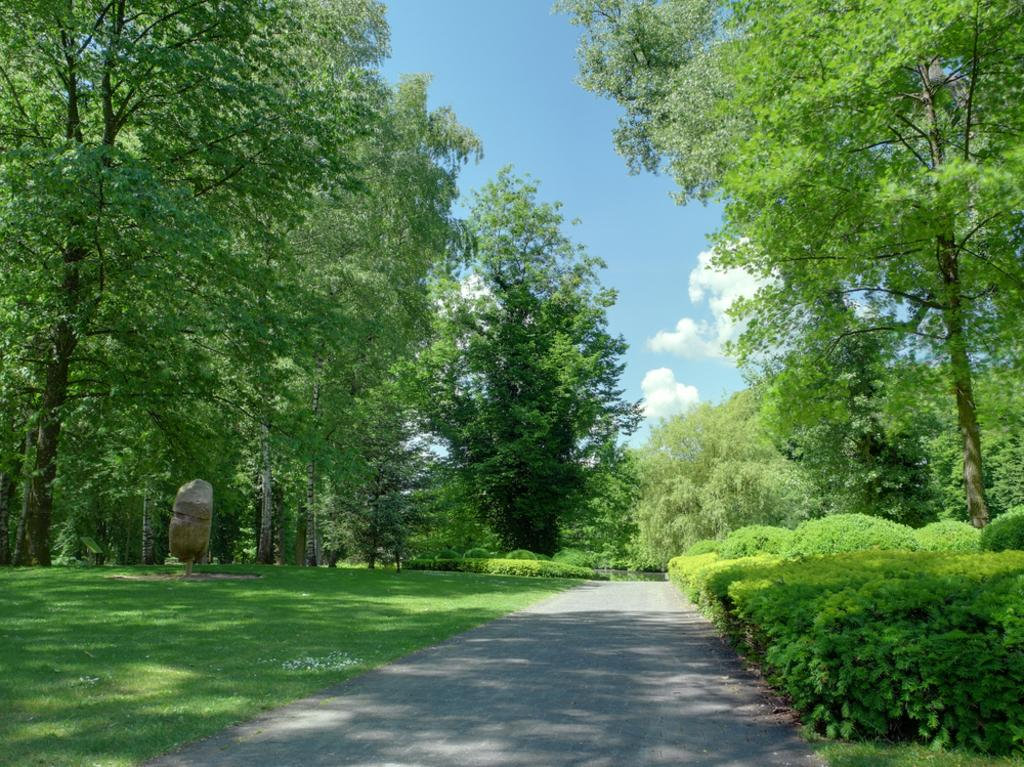What is located at the bottom of the image? There is a road at the bottom of the image. What type of vegetation can be seen on both sides of the image? There are trees on both sides of the image. What type of vegetation is on the left side of the image? There is grass on the left side of the image. What is visible at the top of the image? The sky is visible at the top of the image. Can you see a flock of celery flying in the sky in the image? There is no celery or flock of celery present in the image. What type of smash can be seen happening in the image? There is no smash or any indication of a smash happening in the image. 